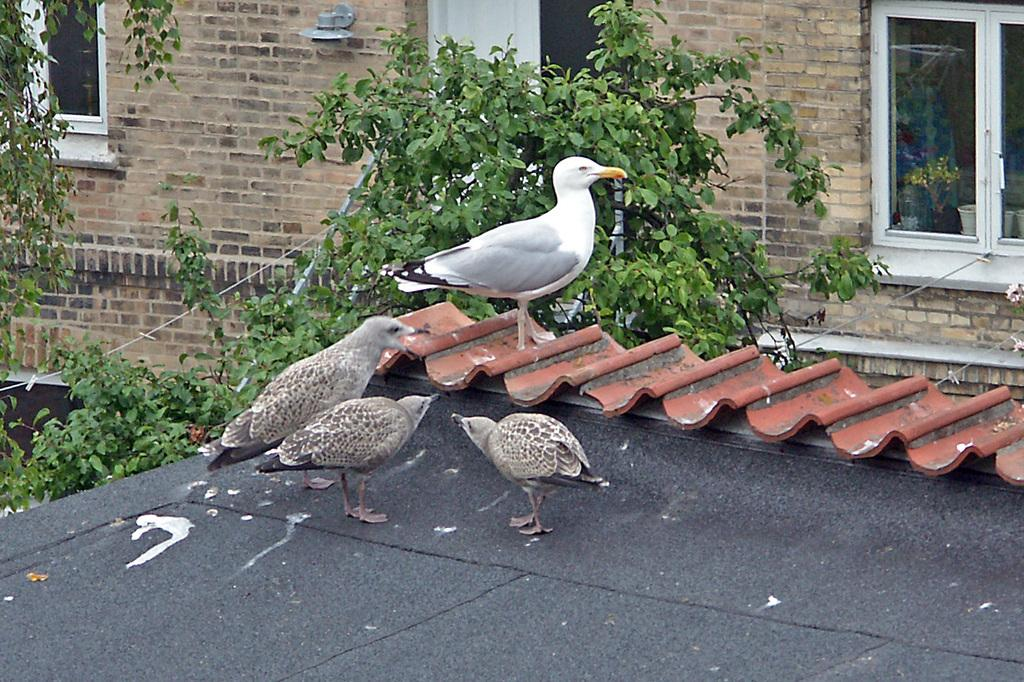What type of animals can be seen on the surface in the image? There are birds on the surface in the image. What type of vegetation is visible in the image? There are leaves visible in the image. What can be seen in the background of the image? There is a wall and windows in the background of the image. What type of van is parked in the room in the image? There is no van present in the image; it features birds on a surface with leaves, and a wall with windows in the background. 